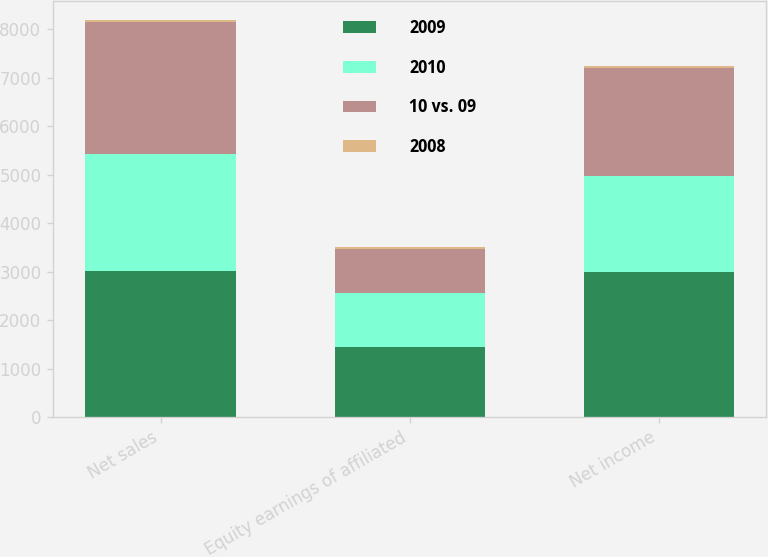<chart> <loc_0><loc_0><loc_500><loc_500><stacked_bar_chart><ecel><fcel>Net sales<fcel>Equity earnings of affiliated<fcel>Net income<nl><fcel>2009<fcel>3011<fcel>1452<fcel>2990<nl><fcel>2010<fcel>2426<fcel>1102<fcel>1992<nl><fcel>10 vs. 09<fcel>2724<fcel>916<fcel>2221<nl><fcel>2008<fcel>24<fcel>32<fcel>50<nl></chart> 